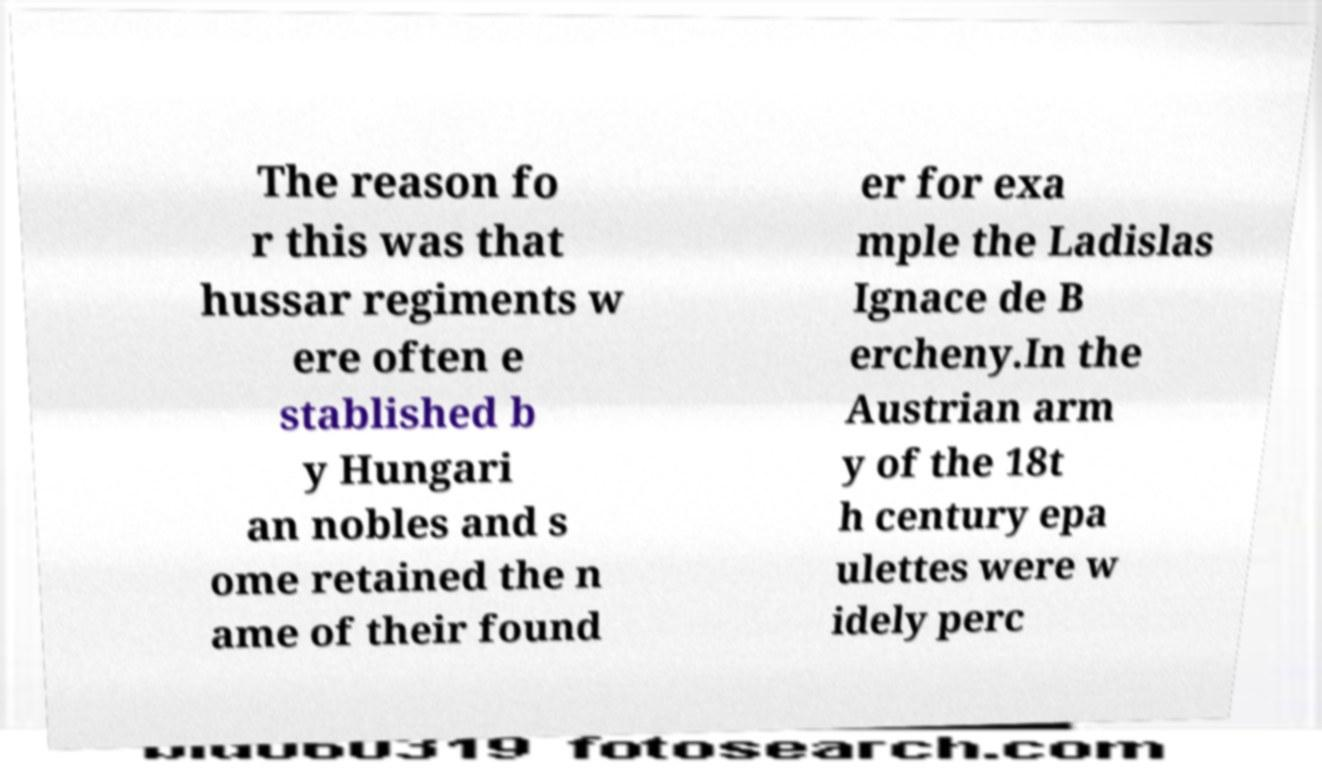Can you accurately transcribe the text from the provided image for me? The reason fo r this was that hussar regiments w ere often e stablished b y Hungari an nobles and s ome retained the n ame of their found er for exa mple the Ladislas Ignace de B ercheny.In the Austrian arm y of the 18t h century epa ulettes were w idely perc 